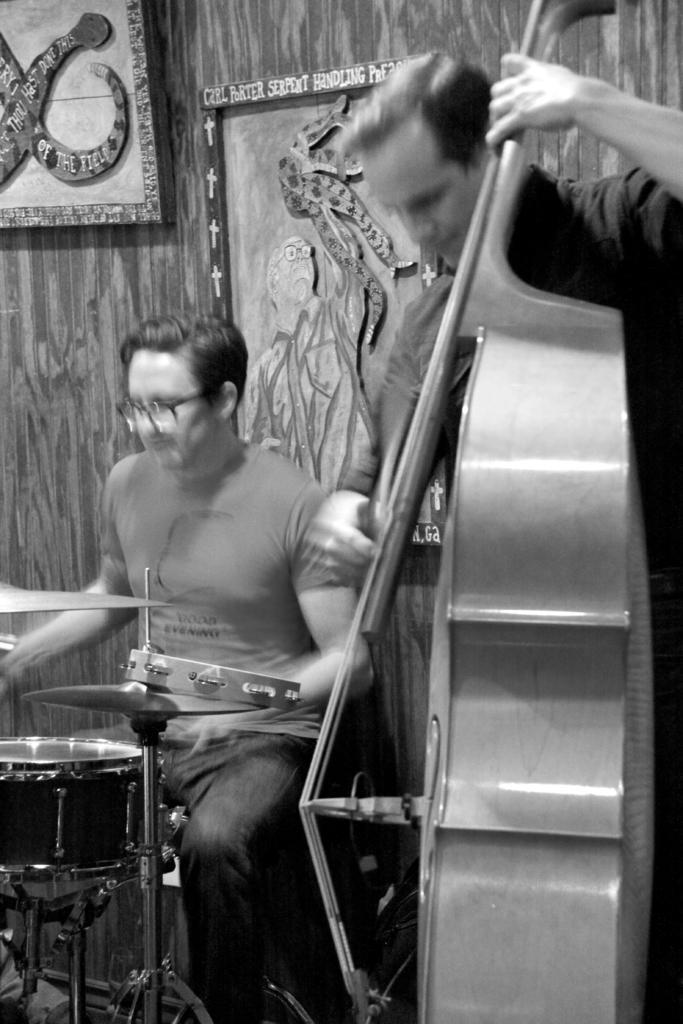Can you describe this image briefly? In this image we can see a black and white picture of two persons. One person is holding a violin in his hands. One person is wearing spectacles. To the left side of the image we can see musical instruments on stands. In the background, we can see photo frames on the wall. 